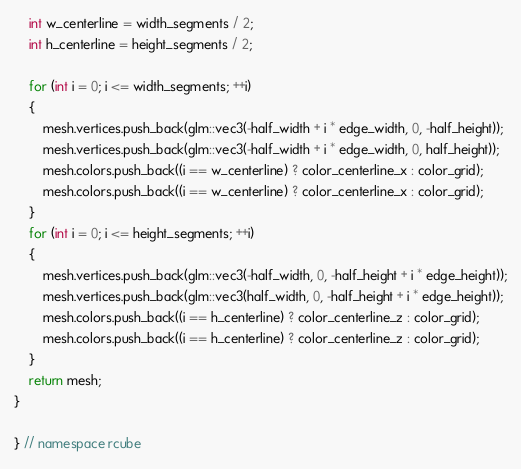<code> <loc_0><loc_0><loc_500><loc_500><_C++_>    int w_centerline = width_segments / 2;
    int h_centerline = height_segments / 2;

    for (int i = 0; i <= width_segments; ++i)
    {
        mesh.vertices.push_back(glm::vec3(-half_width + i * edge_width, 0, -half_height));
        mesh.vertices.push_back(glm::vec3(-half_width + i * edge_width, 0, half_height));
        mesh.colors.push_back((i == w_centerline) ? color_centerline_x : color_grid);
        mesh.colors.push_back((i == w_centerline) ? color_centerline_x : color_grid);
    }
    for (int i = 0; i <= height_segments; ++i)
    {
        mesh.vertices.push_back(glm::vec3(-half_width, 0, -half_height + i * edge_height));
        mesh.vertices.push_back(glm::vec3(half_width, 0, -half_height + i * edge_height));
        mesh.colors.push_back((i == h_centerline) ? color_centerline_z : color_grid);
        mesh.colors.push_back((i == h_centerline) ? color_centerline_z : color_grid);
    }
    return mesh;
}

} // namespace rcube
</code> 